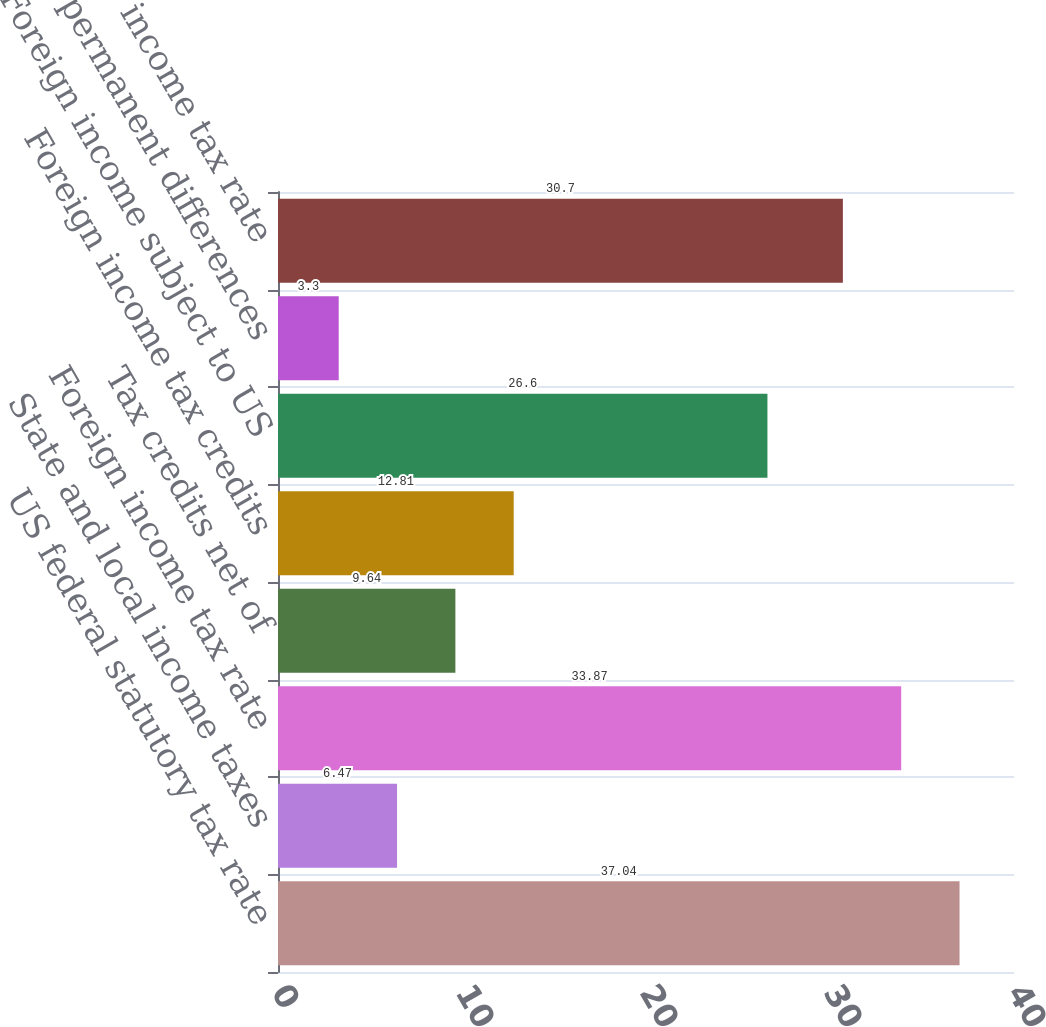Convert chart. <chart><loc_0><loc_0><loc_500><loc_500><bar_chart><fcel>US federal statutory tax rate<fcel>State and local income taxes<fcel>Foreign income tax rate<fcel>Tax credits net of<fcel>Foreign income tax credits<fcel>Foreign income subject to US<fcel>Other permanent differences<fcel>Effective income tax rate<nl><fcel>37.04<fcel>6.47<fcel>33.87<fcel>9.64<fcel>12.81<fcel>26.6<fcel>3.3<fcel>30.7<nl></chart> 